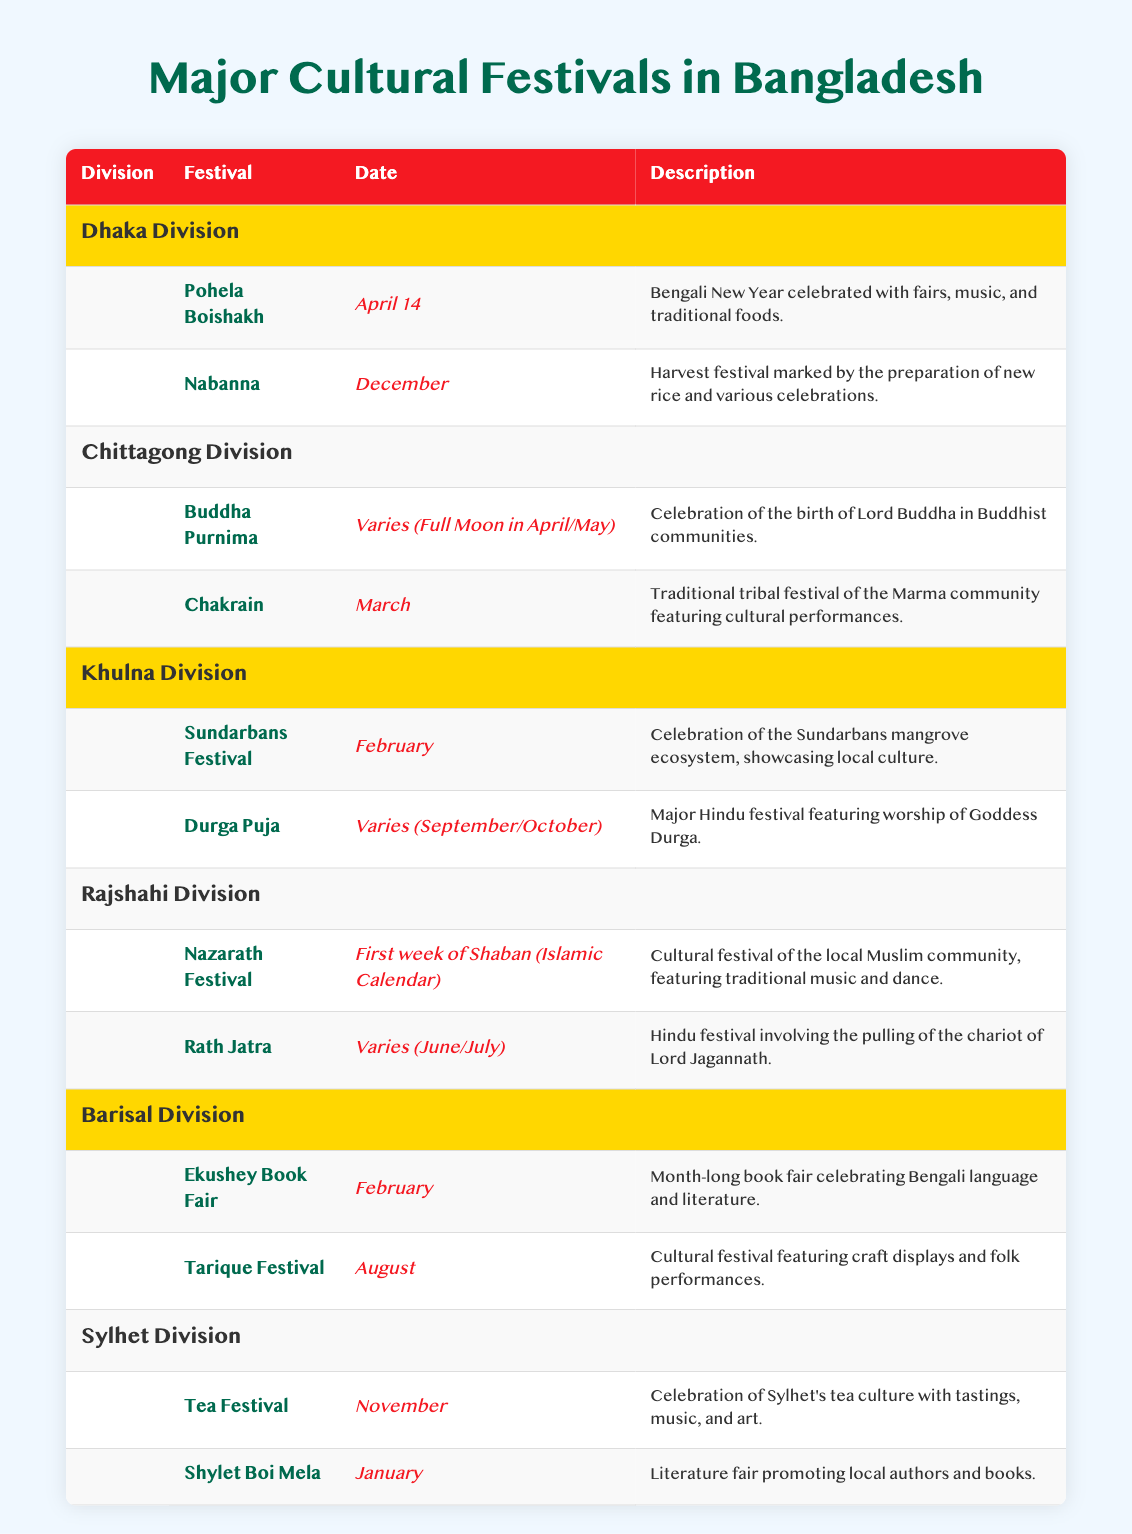What festival is celebrated on April 14 in Dhaka Division? The festival celebrated on April 14 in Dhaka Division is Pohela Boishakh. This can be found in the table under the Dhaka Division where it lists the festival with its corresponding date.
Answer: Pohela Boishakh Which division has the Sundarbans Festival? The Sundarbans Festival is listed under Khulna Division in the table. The division is mentioned right before the festival details.
Answer: Khulna Division Does Rajshahi Division celebrate Durga Puja? No, Durga Puja is not celebrated in Rajshahi Division. It is celebrated in Khulna Division. The festival details in the table provide this information.
Answer: No How many major festivals are listed for Sylhet Division? Sylhet Division has two major festivals listed: Tea Festival and Shylet Boi Mela. The total number of festivals is counted directly from the table under Sylhet Division.
Answer: 2 Which festival in Barisal Division features craft displays and folk performances? The festival in Barisal Division that features craft displays and folk performances is the Tarique Festival. This is found in the Barisal section of the table with its description.
Answer: Tarique Festival What is the date range for Buddha Purnima? Buddha Purnima is celebrated on a date that varies, specifically on the Full Moon in April or May. This information is directly mentioned in the table under Chittagong Division.
Answer: Varies (Full Moon in April/May) Which festival has a month-long celebration in February? The Ekushey Book Fair has a month-long celebration in February. This is seen in the table under Barisal Division where the festival name and its date are mentioned together.
Answer: Ekushey Book Fair What are the two main festivals celebrated in Chittagong Division? The two main festivals celebrated in Chittagong Division are Buddha Purnima and Chakrain. This can be deduced by viewing the festivals listed in that division in the table.
Answer: Buddha Purnima and Chakrain Which division celebrates the Tea Festival in November? The division that celebrates the Tea Festival in November is Sylhet Division. This is indicated in the table where the festival is listed along with its corresponding date.
Answer: Sylhet Division 